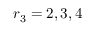Convert formula to latex. <formula><loc_0><loc_0><loc_500><loc_500>r _ { 3 } = 2 , 3 , 4</formula> 